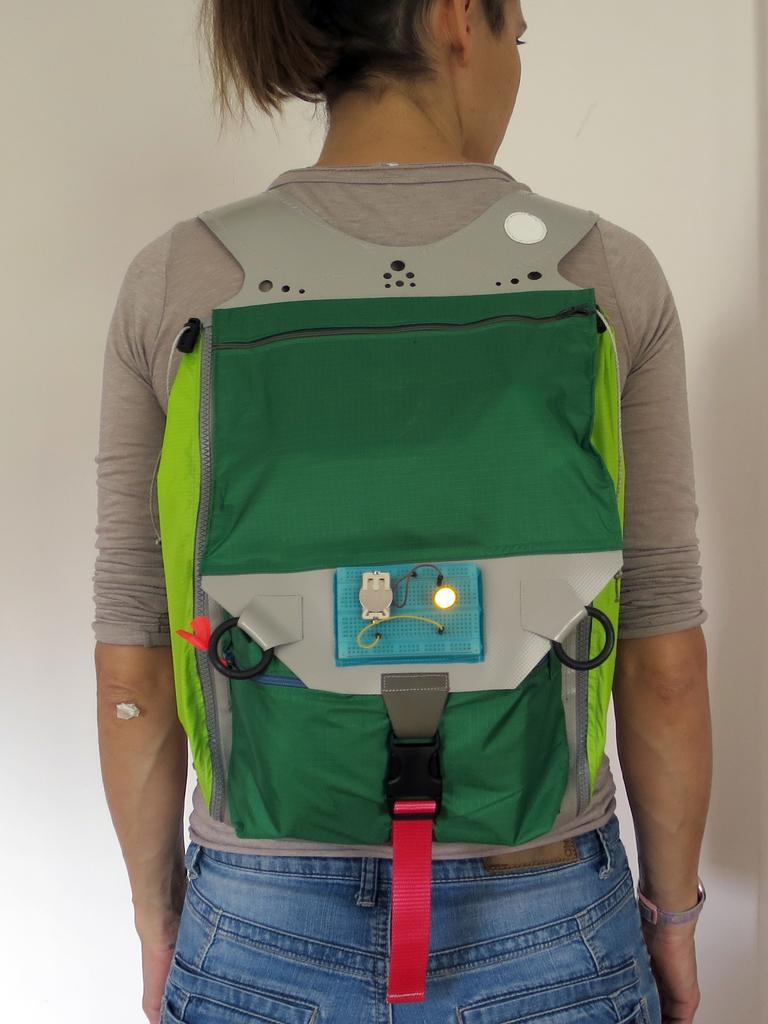Who is present in the image? There is a woman in the image. What is the woman carrying on her back? The woman is wearing a backpack. What type of scent can be detected from the woman's skin in the image? There is no information about the scent of the woman's skin in the image. What type of twig is the woman holding in the image? There is no twig present in the image. 